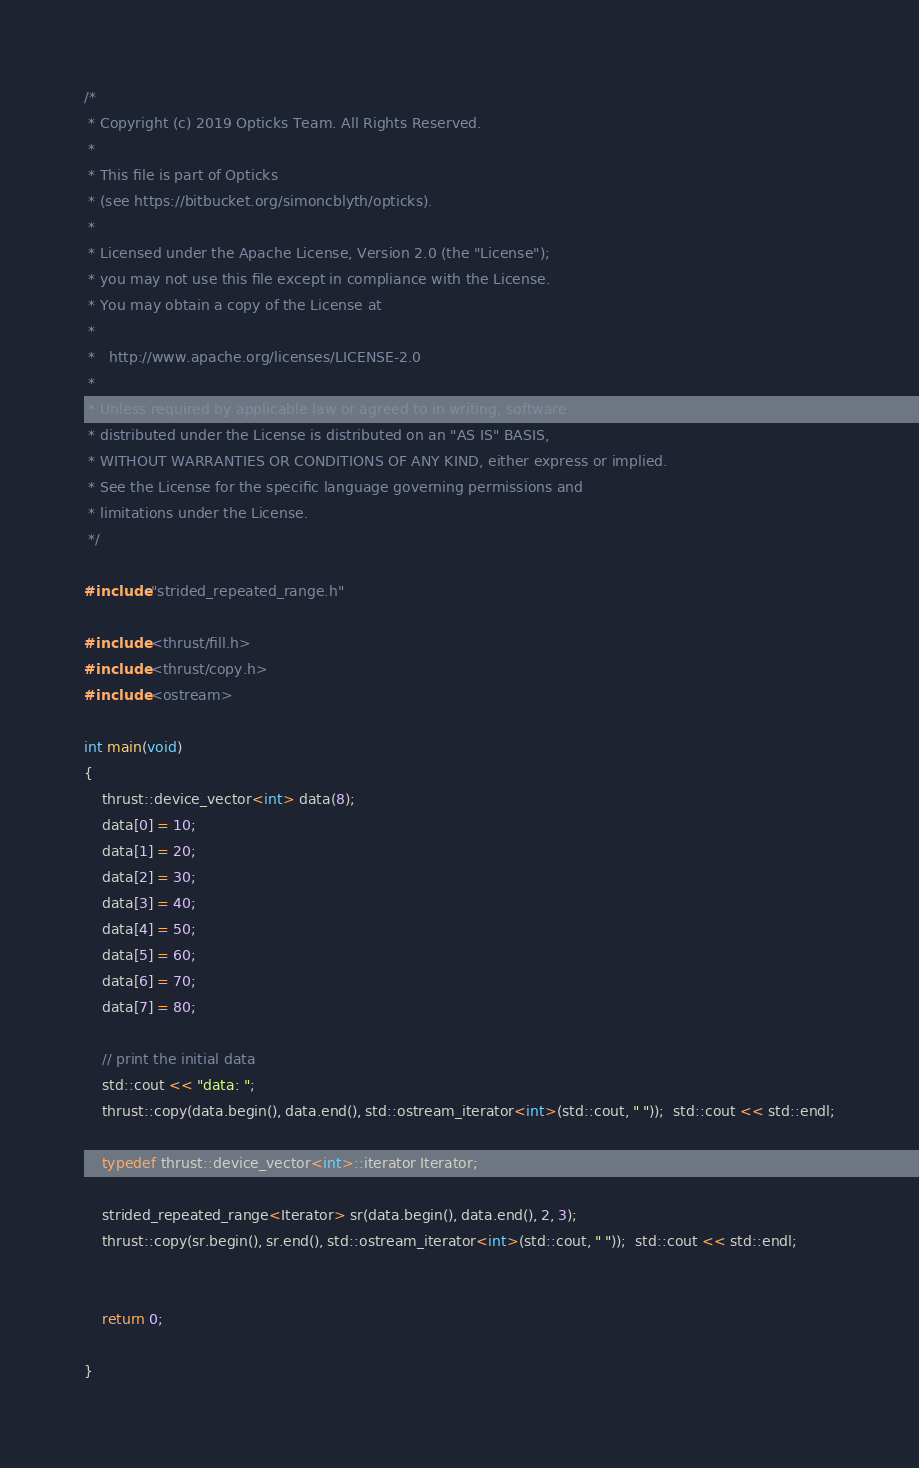<code> <loc_0><loc_0><loc_500><loc_500><_Cuda_>/*
 * Copyright (c) 2019 Opticks Team. All Rights Reserved.
 *
 * This file is part of Opticks
 * (see https://bitbucket.org/simoncblyth/opticks).
 *
 * Licensed under the Apache License, Version 2.0 (the "License"); 
 * you may not use this file except in compliance with the License.  
 * You may obtain a copy of the License at
 *
 *   http://www.apache.org/licenses/LICENSE-2.0
 *
 * Unless required by applicable law or agreed to in writing, software 
 * distributed under the License is distributed on an "AS IS" BASIS, 
 * WITHOUT WARRANTIES OR CONDITIONS OF ANY KIND, either express or implied.  
 * See the License for the specific language governing permissions and 
 * limitations under the License.
 */

#include "strided_repeated_range.h"

#include <thrust/fill.h>
#include <thrust/copy.h>
#include <ostream>

int main(void)
{
    thrust::device_vector<int> data(8);
    data[0] = 10;
    data[1] = 20;
    data[2] = 30;
    data[3] = 40;
    data[4] = 50;
    data[5] = 60;
    data[6] = 70;
    data[7] = 80;

    // print the initial data
    std::cout << "data: ";
    thrust::copy(data.begin(), data.end(), std::ostream_iterator<int>(std::cout, " "));  std::cout << std::endl;

    typedef thrust::device_vector<int>::iterator Iterator;
    
    strided_repeated_range<Iterator> sr(data.begin(), data.end(), 2, 3);
    thrust::copy(sr.begin(), sr.end(), std::ostream_iterator<int>(std::cout, " "));  std::cout << std::endl;


    return 0;

}

</code> 